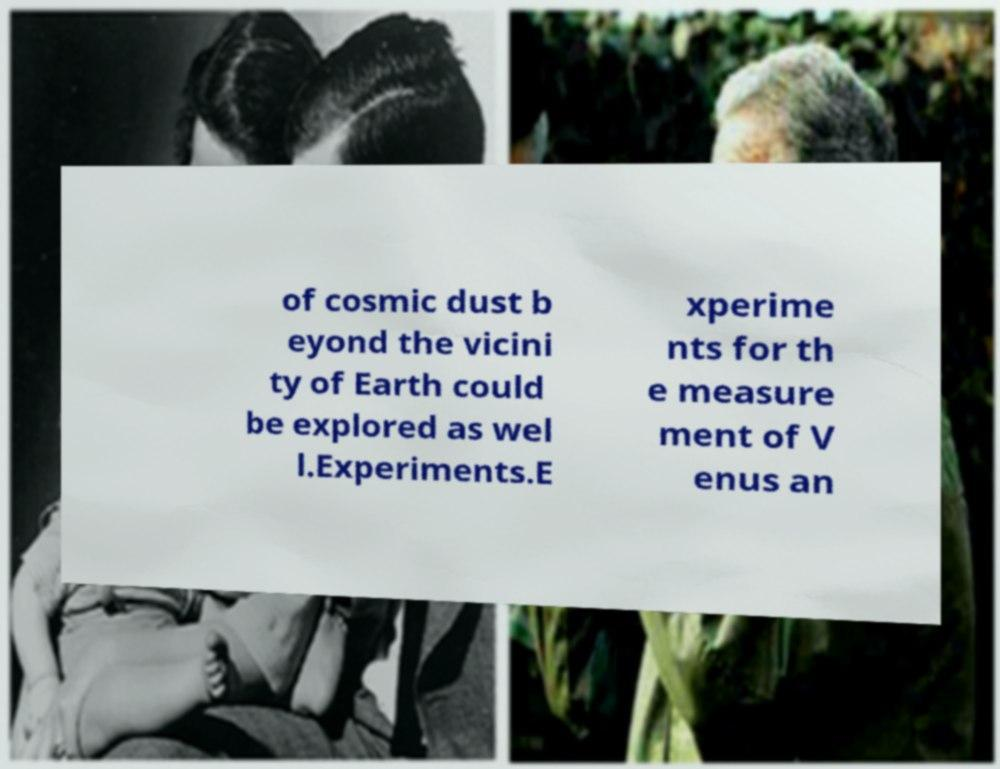I need the written content from this picture converted into text. Can you do that? of cosmic dust b eyond the vicini ty of Earth could be explored as wel l.Experiments.E xperime nts for th e measure ment of V enus an 